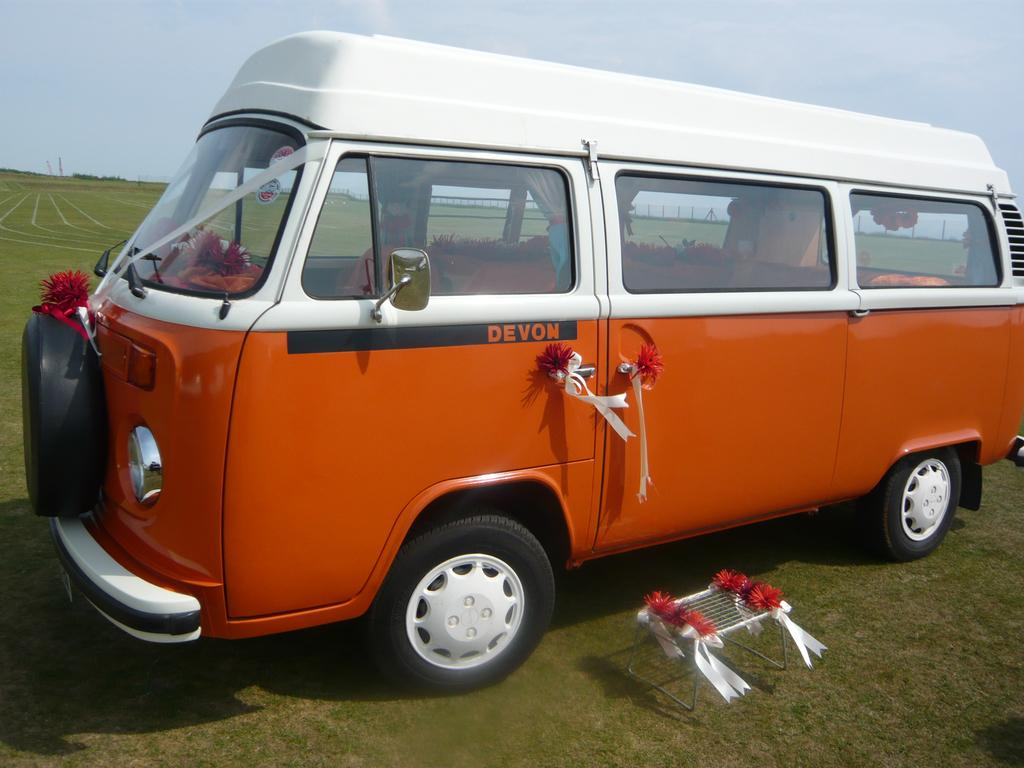Provide a one-sentence caption for the provided image. a DEVON orange and white mini bus parked on a grass field. 